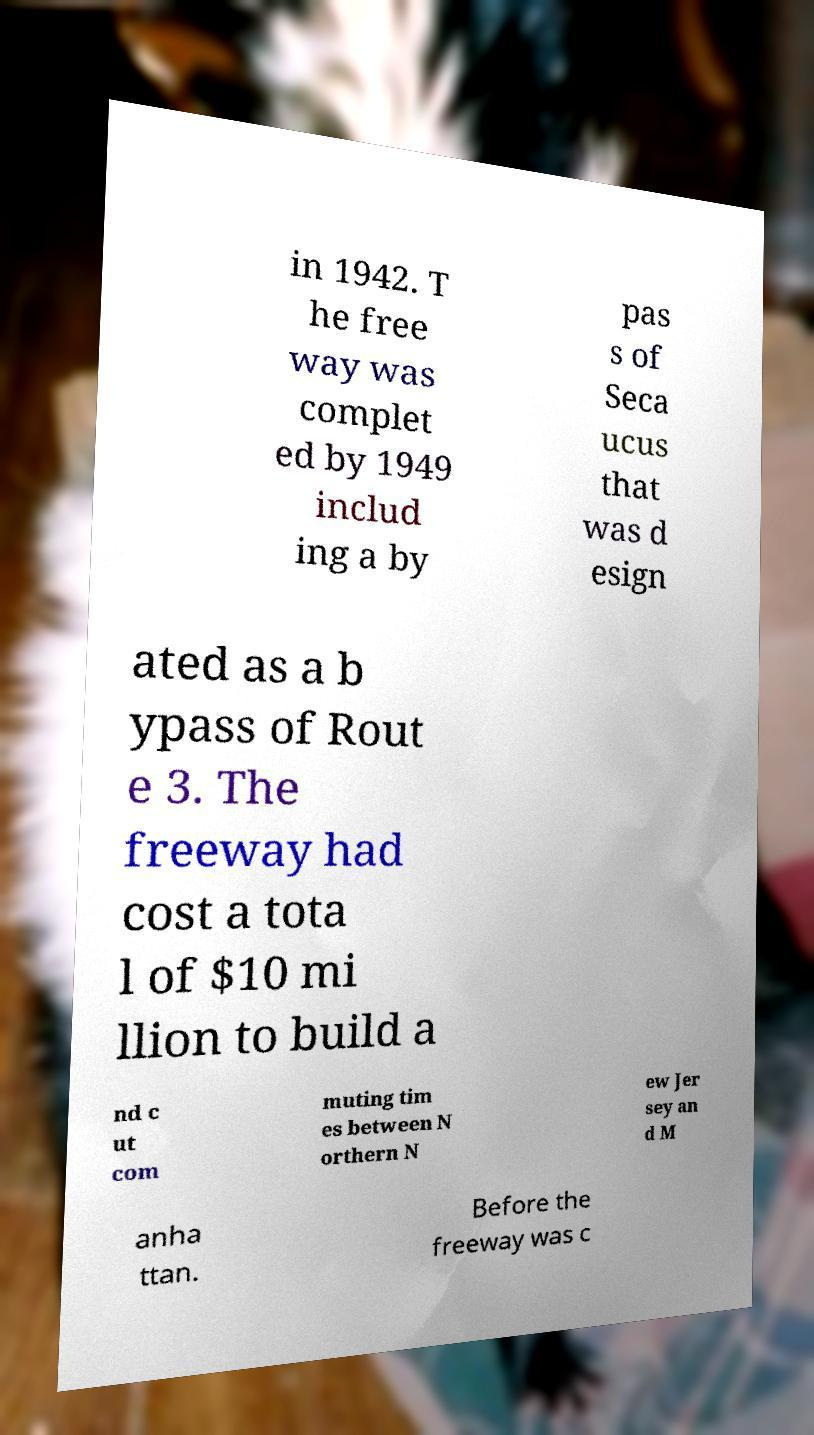Please read and relay the text visible in this image. What does it say? in 1942. T he free way was complet ed by 1949 includ ing a by pas s of Seca ucus that was d esign ated as a b ypass of Rout e 3. The freeway had cost a tota l of $10 mi llion to build a nd c ut com muting tim es between N orthern N ew Jer sey an d M anha ttan. Before the freeway was c 